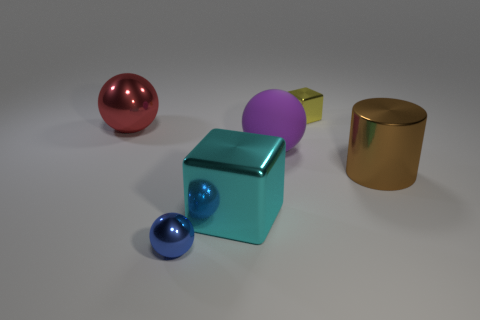Is there any other thing that is the same shape as the brown metal thing?
Give a very brief answer. No. Do the shiny cube to the left of the yellow object and the blue metallic sphere have the same size?
Ensure brevity in your answer.  No. Are there any large red spheres made of the same material as the large cyan thing?
Your answer should be compact. Yes. How many objects are metal blocks that are to the left of the yellow metallic cube or blue rubber spheres?
Offer a terse response. 1. Are there any big brown cubes?
Provide a short and direct response. No. There is a object that is behind the cyan metal cube and on the left side of the cyan cube; what is its shape?
Your answer should be very brief. Sphere. There is a cube that is behind the big red sphere; how big is it?
Your answer should be compact. Small. How many small green metallic objects are the same shape as the big rubber thing?
Your answer should be compact. 0. What number of things are either yellow objects that are behind the large brown metal thing or objects that are behind the large brown metallic object?
Your answer should be compact. 3. What number of blue objects are shiny blocks or balls?
Provide a short and direct response. 1. 